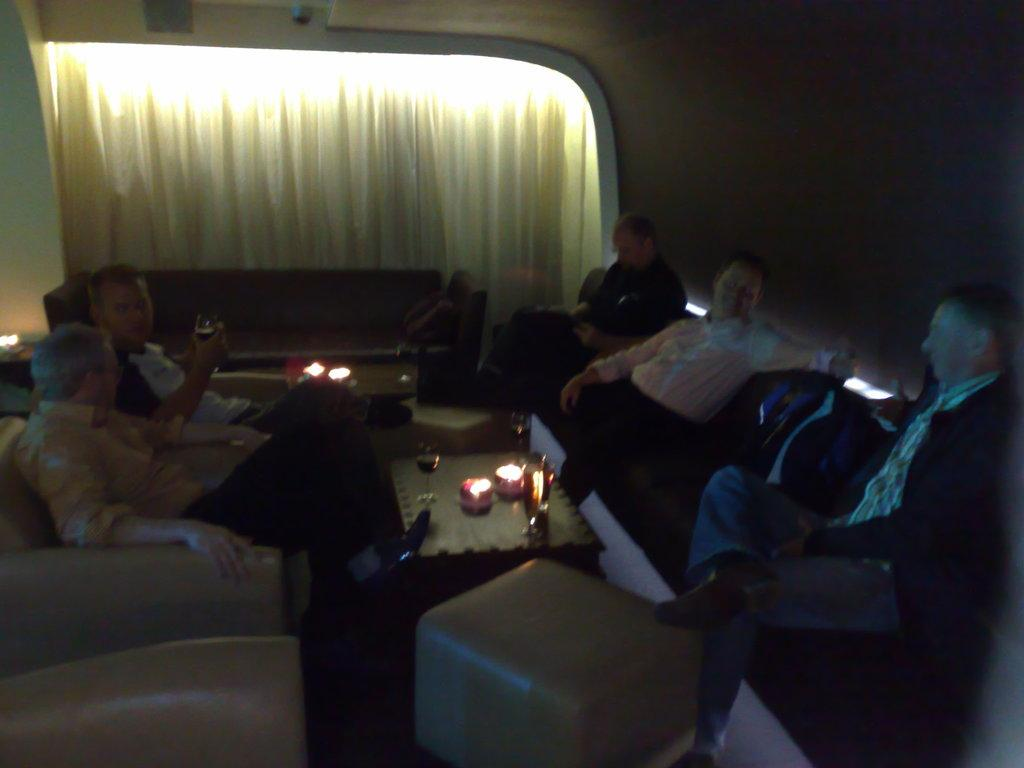What are the persons in the image doing? The persons in the image are sitting on a sofa. What can be seen on the table in the image? There is a glass and a candle on the table in the image. What is in the background of the image? There is a curtain in the background of the image. What type of base is supporting the plough in the image? There is no plough or base present in the image. How many steps are visible in the image? There are no steps visible in the image. 